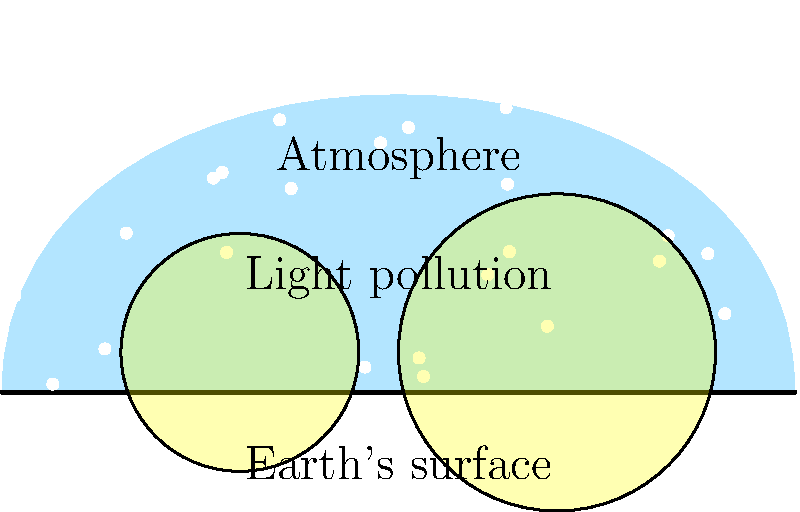How does the visual appearance of stars differ when observed from Earth's surface compared to space, and what role does light pollution play in this difference? 1. Atmospheric effects:
   - Earth's atmosphere scatters and refracts light, causing stars to twinkle and appear less sharp.
   - In space, there's no atmosphere, so stars appear as steady, sharp points of light.

2. Light pollution:
   - On Earth, artificial light from cities and towns creates a sky glow, as shown in the image.
   - This sky glow reduces the contrast between stars and the background sky, making fainter stars invisible.
   - In space, there's no light pollution, allowing for a much darker background.

3. Number of visible stars:
   - Due to atmospheric effects and light pollution, fewer stars are visible from Earth's surface.
   - In space, many more stars are visible, and the Milky Way is clearly apparent.

4. Color perception:
   - Earth's atmosphere can alter the perceived color of stars, especially near the horizon.
   - In space, star colors are more vivid and true to their actual spectral emission.

5. Magnitude limit:
   - On Earth, the faintest stars visible to the naked eye are typically magnitude 6 in dark sites.
   - In space, the magnitude limit is much fainter, potentially reaching magnitude 7 or 8.

6. Stability of view:
   - Earth-based observations are affected by atmospheric turbulence, causing image distortion.
   - Space-based observations provide a stable view, allowing for longer exposure times and clearer images.
Answer: In space: steady, sharp, more numerous, vivid colors. On Earth: twinkling, fewer visible, colors altered by atmosphere and light pollution. 